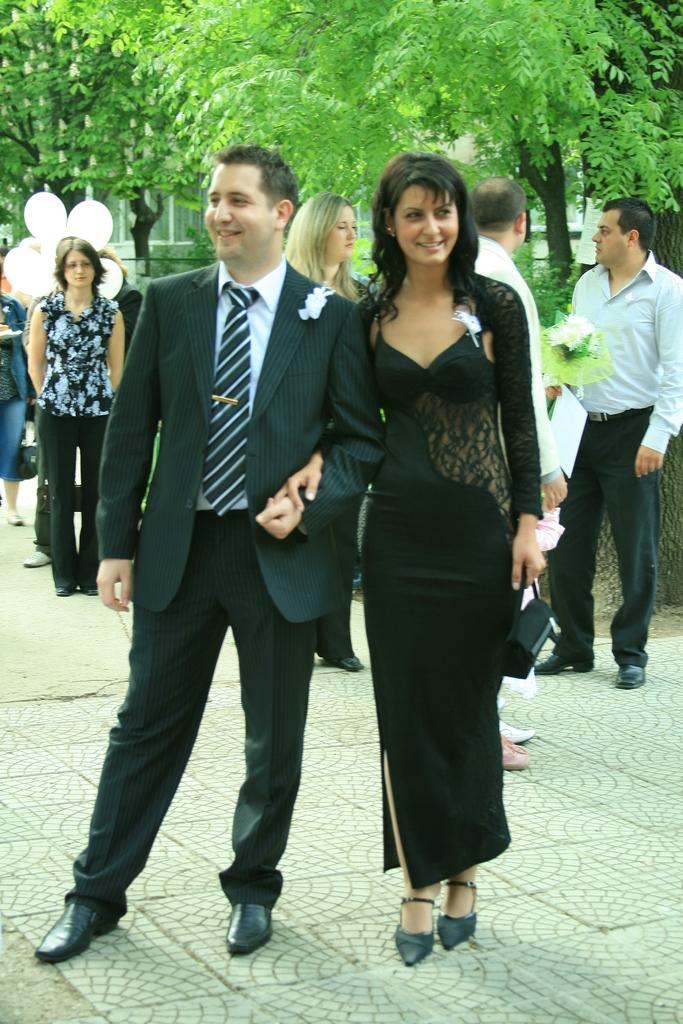How many people are visible in the image? There is a man and a woman standing in the image, making a total of two people. What is the woman holding in her hand? The woman is holding something in her hand, but the specific object cannot be determined from the image. What can be seen in the background of the image? There are many people, balloons, and trees in the background of the image. Is there any quicksand present in the image? There is no quicksand present in the image. What is the woman's mind thinking about in the image? The image does not provide any information about the woman's thoughts or mental state. 